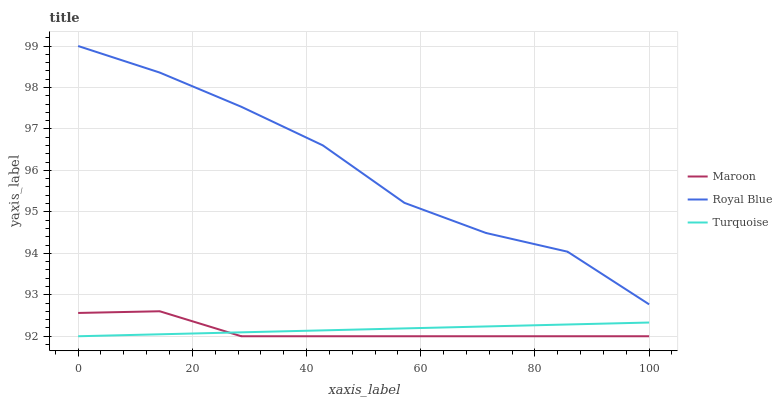Does Maroon have the minimum area under the curve?
Answer yes or no. Yes. Does Turquoise have the minimum area under the curve?
Answer yes or no. No. Does Turquoise have the maximum area under the curve?
Answer yes or no. No. Is Royal Blue the roughest?
Answer yes or no. Yes. Is Maroon the smoothest?
Answer yes or no. No. Is Maroon the roughest?
Answer yes or no. No. Does Maroon have the highest value?
Answer yes or no. No. Is Maroon less than Royal Blue?
Answer yes or no. Yes. Is Royal Blue greater than Turquoise?
Answer yes or no. Yes. Does Maroon intersect Royal Blue?
Answer yes or no. No. 